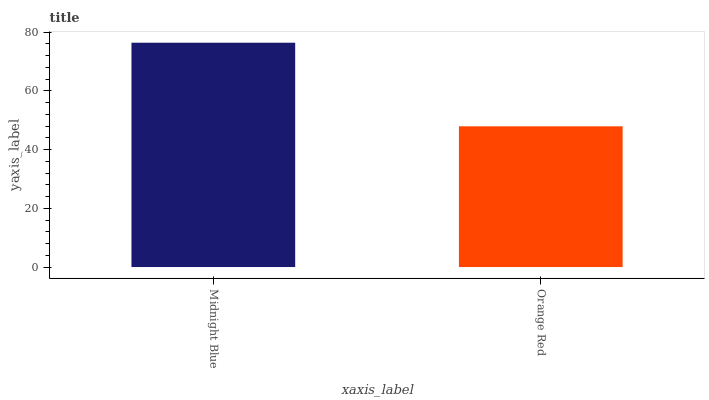Is Orange Red the minimum?
Answer yes or no. Yes. Is Midnight Blue the maximum?
Answer yes or no. Yes. Is Orange Red the maximum?
Answer yes or no. No. Is Midnight Blue greater than Orange Red?
Answer yes or no. Yes. Is Orange Red less than Midnight Blue?
Answer yes or no. Yes. Is Orange Red greater than Midnight Blue?
Answer yes or no. No. Is Midnight Blue less than Orange Red?
Answer yes or no. No. Is Midnight Blue the high median?
Answer yes or no. Yes. Is Orange Red the low median?
Answer yes or no. Yes. Is Orange Red the high median?
Answer yes or no. No. Is Midnight Blue the low median?
Answer yes or no. No. 